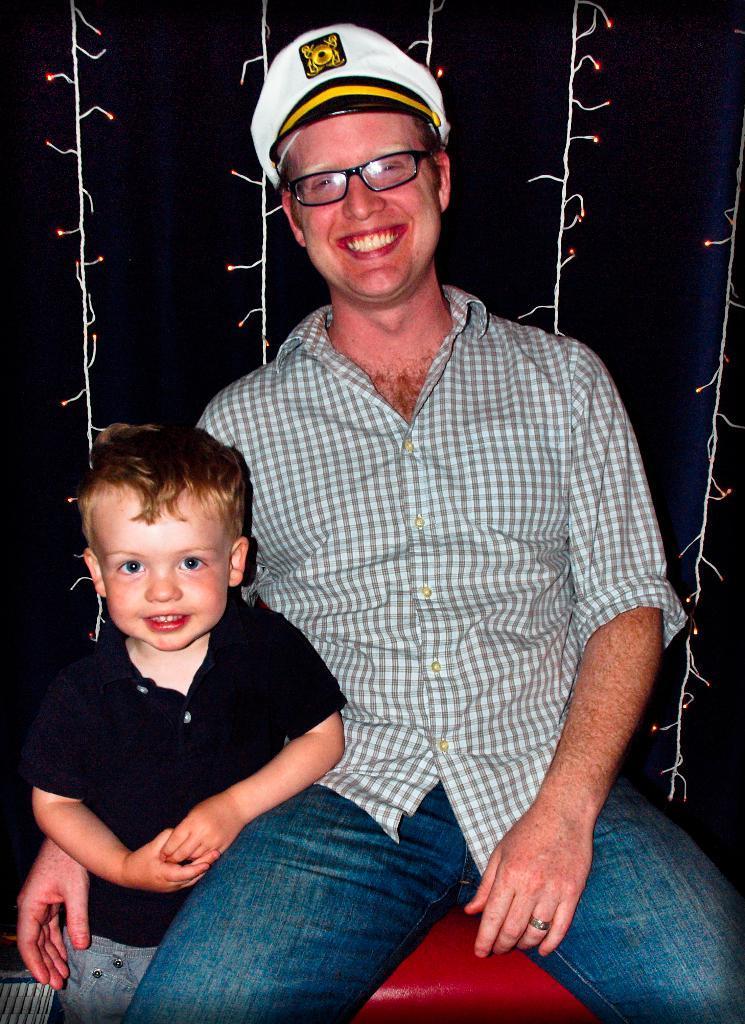How would you summarize this image in a sentence or two? This image is taken outdoors. In this image the background is dark and there are a few rope lights. In the middle of the image a man is sitting on the chair and he is with a smiling face and a kid is standing and he is with a smiling face. The man has worn a cap, spectacles, a shirt and jeans. 